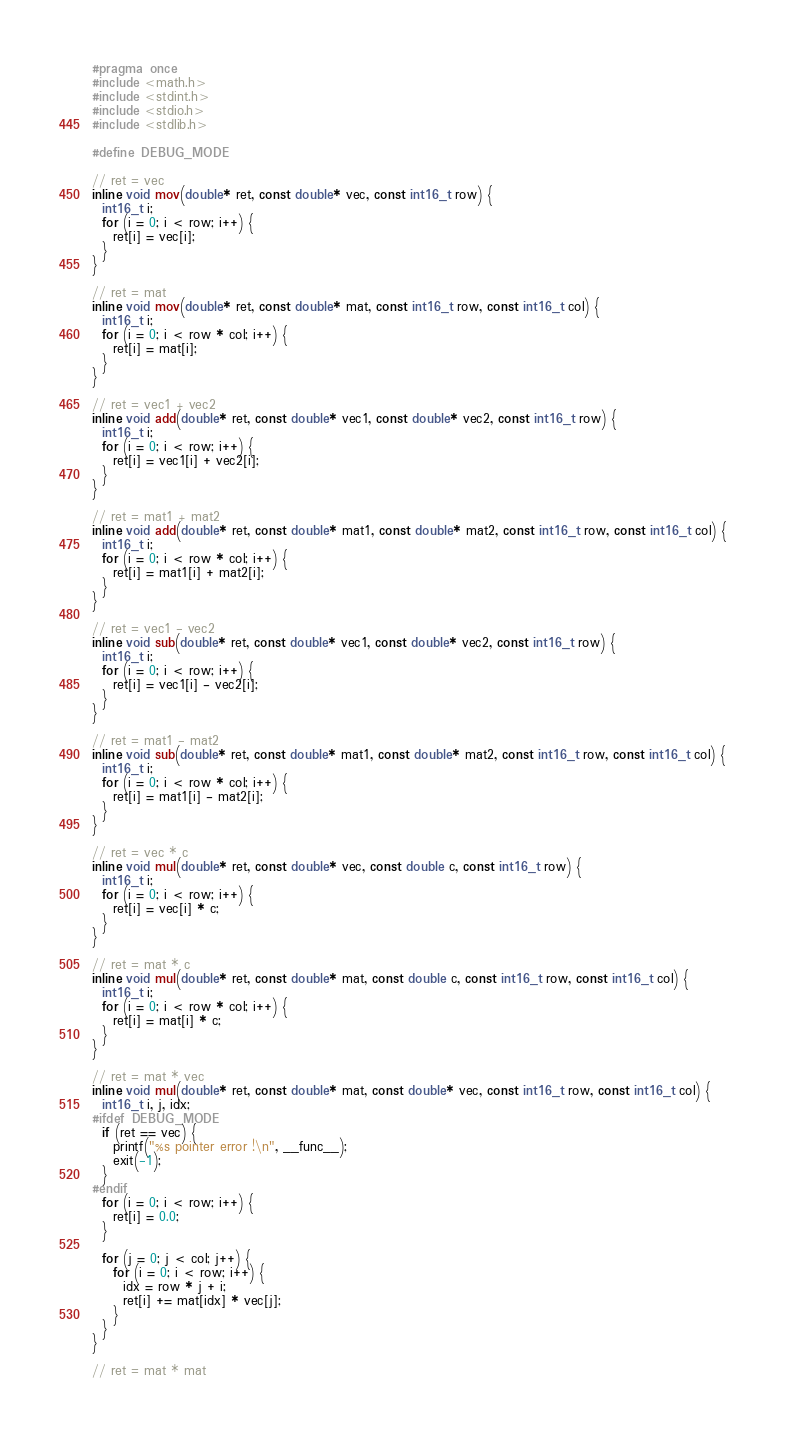<code> <loc_0><loc_0><loc_500><loc_500><_C++_>#pragma once
#include <math.h>
#include <stdint.h>
#include <stdio.h>
#include <stdlib.h>

#define DEBUG_MODE

// ret = vec
inline void mov(double* ret, const double* vec, const int16_t row) {
  int16_t i;
  for (i = 0; i < row; i++) {
    ret[i] = vec[i];
  }
}

// ret = mat
inline void mov(double* ret, const double* mat, const int16_t row, const int16_t col) {
  int16_t i;
  for (i = 0; i < row * col; i++) {
    ret[i] = mat[i];
  }
}

// ret = vec1 + vec2
inline void add(double* ret, const double* vec1, const double* vec2, const int16_t row) {
  int16_t i;
  for (i = 0; i < row; i++) {
    ret[i] = vec1[i] + vec2[i];
  }
}

// ret = mat1 + mat2
inline void add(double* ret, const double* mat1, const double* mat2, const int16_t row, const int16_t col) {
  int16_t i;
  for (i = 0; i < row * col; i++) {
    ret[i] = mat1[i] + mat2[i];
  }
}

// ret = vec1 - vec2
inline void sub(double* ret, const double* vec1, const double* vec2, const int16_t row) {
  int16_t i;
  for (i = 0; i < row; i++) {
    ret[i] = vec1[i] - vec2[i];
  }
}

// ret = mat1 - mat2
inline void sub(double* ret, const double* mat1, const double* mat2, const int16_t row, const int16_t col) {
  int16_t i;
  for (i = 0; i < row * col; i++) {
    ret[i] = mat1[i] - mat2[i];
  }
}

// ret = vec * c
inline void mul(double* ret, const double* vec, const double c, const int16_t row) {
  int16_t i;
  for (i = 0; i < row; i++) {
    ret[i] = vec[i] * c;
  }
}

// ret = mat * c
inline void mul(double* ret, const double* mat, const double c, const int16_t row, const int16_t col) {
  int16_t i;
  for (i = 0; i < row * col; i++) {
    ret[i] = mat[i] * c;
  }
}

// ret = mat * vec
inline void mul(double* ret, const double* mat, const double* vec, const int16_t row, const int16_t col) {
  int16_t i, j, idx;
#ifdef DEBUG_MODE
  if (ret == vec) {
    printf("%s pointer error !\n", __func__);
    exit(-1);
  }
#endif
  for (i = 0; i < row; i++) {
    ret[i] = 0.0;
  }

  for (j = 0; j < col; j++) {
    for (i = 0; i < row; i++) {
      idx = row * j + i;
      ret[i] += mat[idx] * vec[j];
    }
  }
}

// ret = mat * mat</code> 